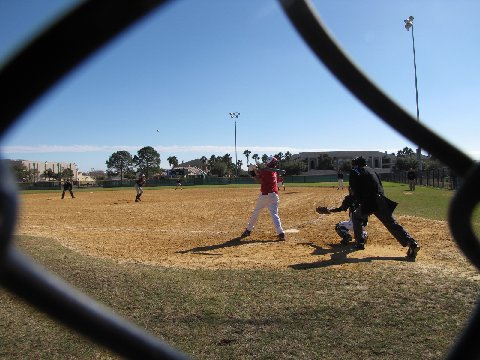What is one of the baseball players doing in the image? Captured in a pivotal moment, one of the young players expertly grips his bat mid-swing, focusing intently on the incoming baseball as he aims to hit it with precision and power, a testament to the skill and concentration nurtured at this developmental stage of the sport. 